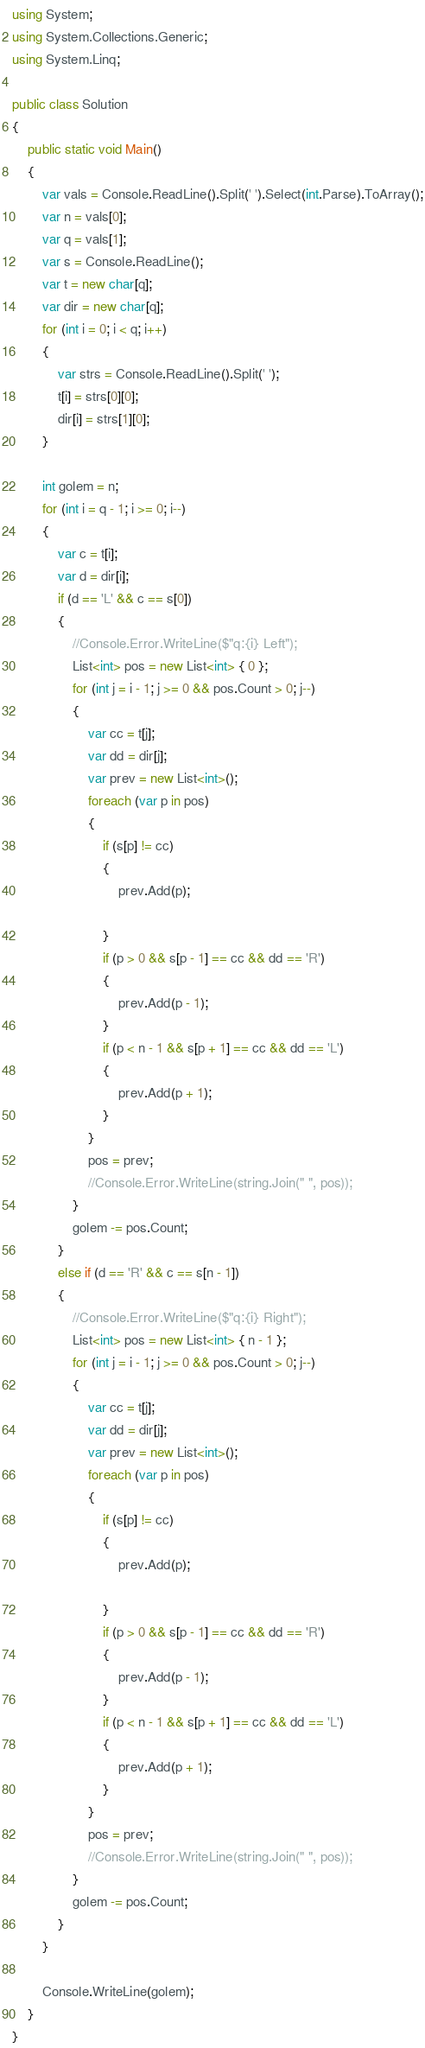Convert code to text. <code><loc_0><loc_0><loc_500><loc_500><_C#_>using System;
using System.Collections.Generic;
using System.Linq;

public class Solution
{
    public static void Main()
    {
        var vals = Console.ReadLine().Split(' ').Select(int.Parse).ToArray();
        var n = vals[0];
        var q = vals[1];
        var s = Console.ReadLine();
        var t = new char[q];
        var dir = new char[q];
        for (int i = 0; i < q; i++)
        {
            var strs = Console.ReadLine().Split(' ');
            t[i] = strs[0][0];
            dir[i] = strs[1][0];
        }

        int golem = n;
        for (int i = q - 1; i >= 0; i--)
        {
            var c = t[i];
            var d = dir[i];
            if (d == 'L' && c == s[0])
            {
                //Console.Error.WriteLine($"q:{i} Left");
                List<int> pos = new List<int> { 0 };
                for (int j = i - 1; j >= 0 && pos.Count > 0; j--)
                {
                    var cc = t[j];
                    var dd = dir[j];
                    var prev = new List<int>();
                    foreach (var p in pos)
                    {
                        if (s[p] != cc)
                        {
                            prev.Add(p);

                        }
                        if (p > 0 && s[p - 1] == cc && dd == 'R')
                        {
                            prev.Add(p - 1);
                        }
                        if (p < n - 1 && s[p + 1] == cc && dd == 'L')
                        {
                            prev.Add(p + 1);
                        }
                    }
                    pos = prev;
                    //Console.Error.WriteLine(string.Join(" ", pos));
                }
                golem -= pos.Count;
            }
            else if (d == 'R' && c == s[n - 1])
            {
                //Console.Error.WriteLine($"q:{i} Right");
                List<int> pos = new List<int> { n - 1 };
                for (int j = i - 1; j >= 0 && pos.Count > 0; j--)
                {
                    var cc = t[j];
                    var dd = dir[j];
                    var prev = new List<int>();
                    foreach (var p in pos)
                    {
                        if (s[p] != cc)
                        {
                            prev.Add(p);

                        }
                        if (p > 0 && s[p - 1] == cc && dd == 'R')
                        {
                            prev.Add(p - 1);
                        }
                        if (p < n - 1 && s[p + 1] == cc && dd == 'L')
                        {
                            prev.Add(p + 1);
                        }
                    }
                    pos = prev;
                    //Console.Error.WriteLine(string.Join(" ", pos));
                }
                golem -= pos.Count;
            }
        }

        Console.WriteLine(golem);
    }
}</code> 